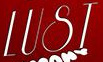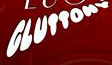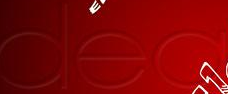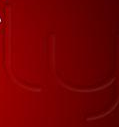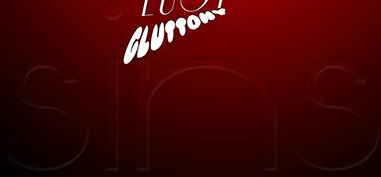Identify the words shown in these images in order, separated by a semicolon. LUST; GLUTTONV; dea; ly; sins 